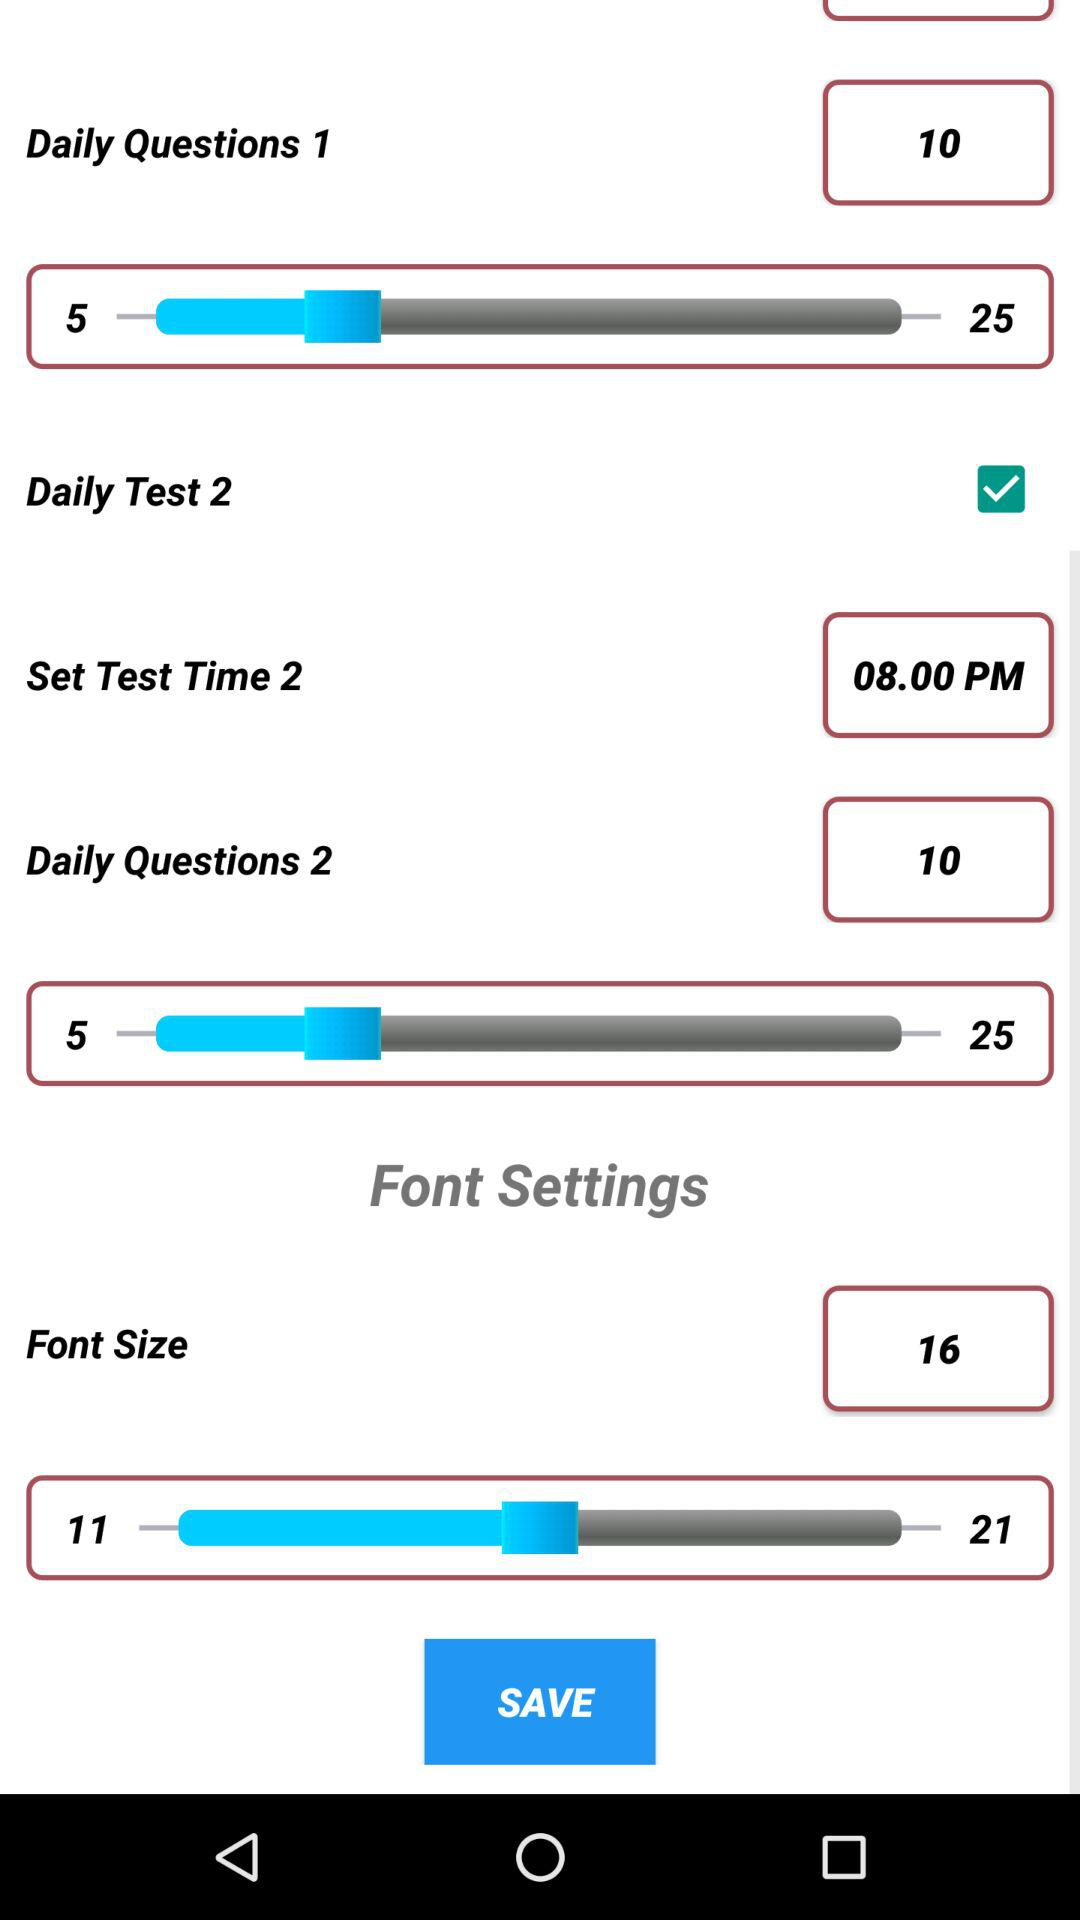What is the set time for test 2? The set time for test 2 is 08:00 PM. 